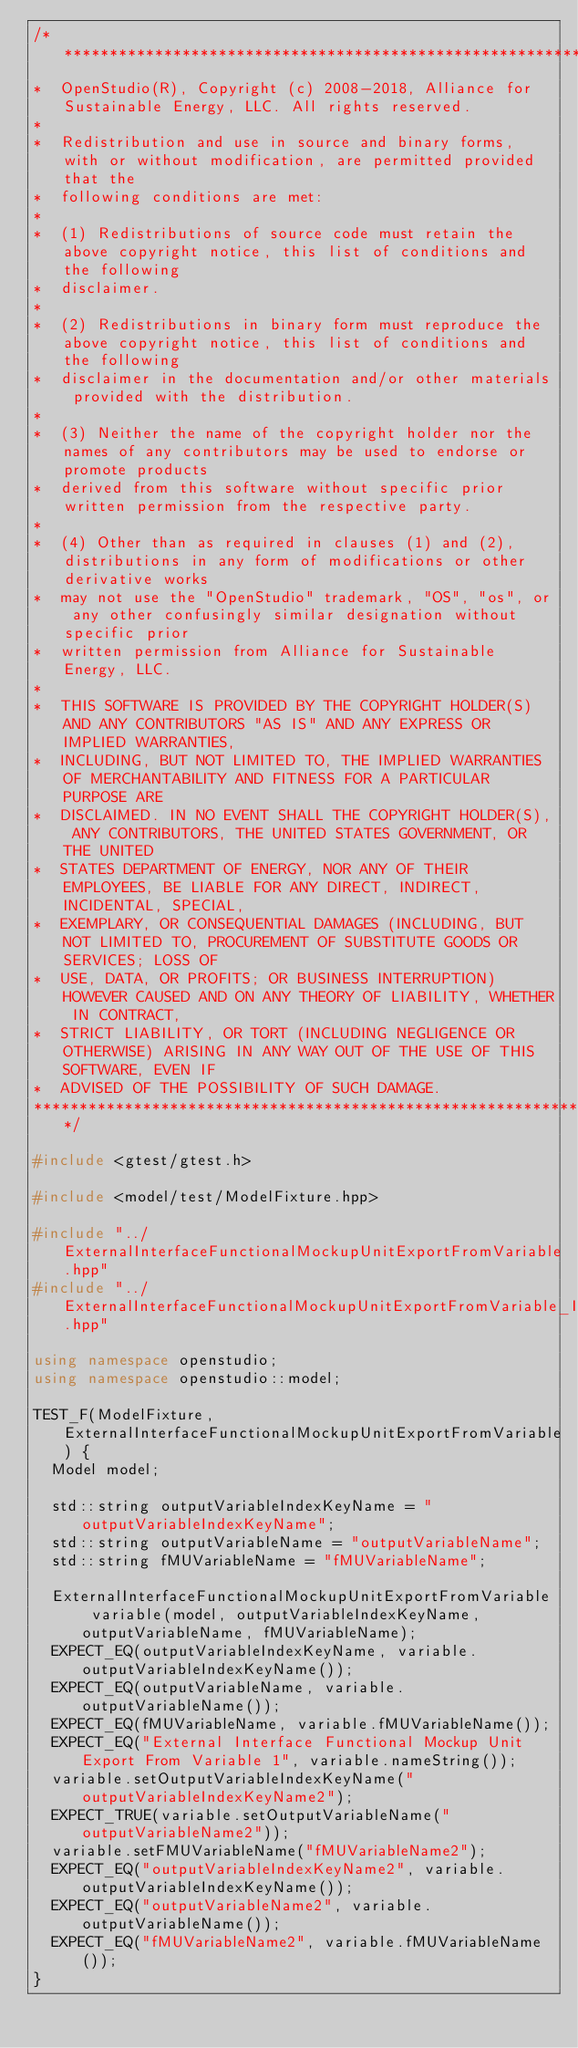Convert code to text. <code><loc_0><loc_0><loc_500><loc_500><_C++_>/***********************************************************************************************************************
*  OpenStudio(R), Copyright (c) 2008-2018, Alliance for Sustainable Energy, LLC. All rights reserved.
*
*  Redistribution and use in source and binary forms, with or without modification, are permitted provided that the
*  following conditions are met:
*
*  (1) Redistributions of source code must retain the above copyright notice, this list of conditions and the following
*  disclaimer.
*
*  (2) Redistributions in binary form must reproduce the above copyright notice, this list of conditions and the following
*  disclaimer in the documentation and/or other materials provided with the distribution.
*
*  (3) Neither the name of the copyright holder nor the names of any contributors may be used to endorse or promote products
*  derived from this software without specific prior written permission from the respective party.
*
*  (4) Other than as required in clauses (1) and (2), distributions in any form of modifications or other derivative works
*  may not use the "OpenStudio" trademark, "OS", "os", or any other confusingly similar designation without specific prior
*  written permission from Alliance for Sustainable Energy, LLC.
*
*  THIS SOFTWARE IS PROVIDED BY THE COPYRIGHT HOLDER(S) AND ANY CONTRIBUTORS "AS IS" AND ANY EXPRESS OR IMPLIED WARRANTIES,
*  INCLUDING, BUT NOT LIMITED TO, THE IMPLIED WARRANTIES OF MERCHANTABILITY AND FITNESS FOR A PARTICULAR PURPOSE ARE
*  DISCLAIMED. IN NO EVENT SHALL THE COPYRIGHT HOLDER(S), ANY CONTRIBUTORS, THE UNITED STATES GOVERNMENT, OR THE UNITED
*  STATES DEPARTMENT OF ENERGY, NOR ANY OF THEIR EMPLOYEES, BE LIABLE FOR ANY DIRECT, INDIRECT, INCIDENTAL, SPECIAL,
*  EXEMPLARY, OR CONSEQUENTIAL DAMAGES (INCLUDING, BUT NOT LIMITED TO, PROCUREMENT OF SUBSTITUTE GOODS OR SERVICES; LOSS OF
*  USE, DATA, OR PROFITS; OR BUSINESS INTERRUPTION) HOWEVER CAUSED AND ON ANY THEORY OF LIABILITY, WHETHER IN CONTRACT,
*  STRICT LIABILITY, OR TORT (INCLUDING NEGLIGENCE OR OTHERWISE) ARISING IN ANY WAY OUT OF THE USE OF THIS SOFTWARE, EVEN IF
*  ADVISED OF THE POSSIBILITY OF SUCH DAMAGE.
***********************************************************************************************************************/

#include <gtest/gtest.h>

#include <model/test/ModelFixture.hpp>

#include "../ExternalInterfaceFunctionalMockupUnitExportFromVariable.hpp"
#include "../ExternalInterfaceFunctionalMockupUnitExportFromVariable_Impl.hpp"

using namespace openstudio;
using namespace openstudio::model;

TEST_F(ModelFixture, ExternalInterfaceFunctionalMockupUnitExportFromVariable) {
  Model model;

  std::string outputVariableIndexKeyName = "outputVariableIndexKeyName";
  std::string outputVariableName = "outputVariableName";
  std::string fMUVariableName = "fMUVariableName";

  ExternalInterfaceFunctionalMockupUnitExportFromVariable variable(model, outputVariableIndexKeyName, outputVariableName, fMUVariableName);
  EXPECT_EQ(outputVariableIndexKeyName, variable.outputVariableIndexKeyName());
  EXPECT_EQ(outputVariableName, variable.outputVariableName());
  EXPECT_EQ(fMUVariableName, variable.fMUVariableName());
  EXPECT_EQ("External Interface Functional Mockup Unit Export From Variable 1", variable.nameString());
  variable.setOutputVariableIndexKeyName("outputVariableIndexKeyName2");
  EXPECT_TRUE(variable.setOutputVariableName("outputVariableName2"));
  variable.setFMUVariableName("fMUVariableName2");
  EXPECT_EQ("outputVariableIndexKeyName2", variable.outputVariableIndexKeyName());
  EXPECT_EQ("outputVariableName2", variable.outputVariableName());
  EXPECT_EQ("fMUVariableName2", variable.fMUVariableName());
}
</code> 